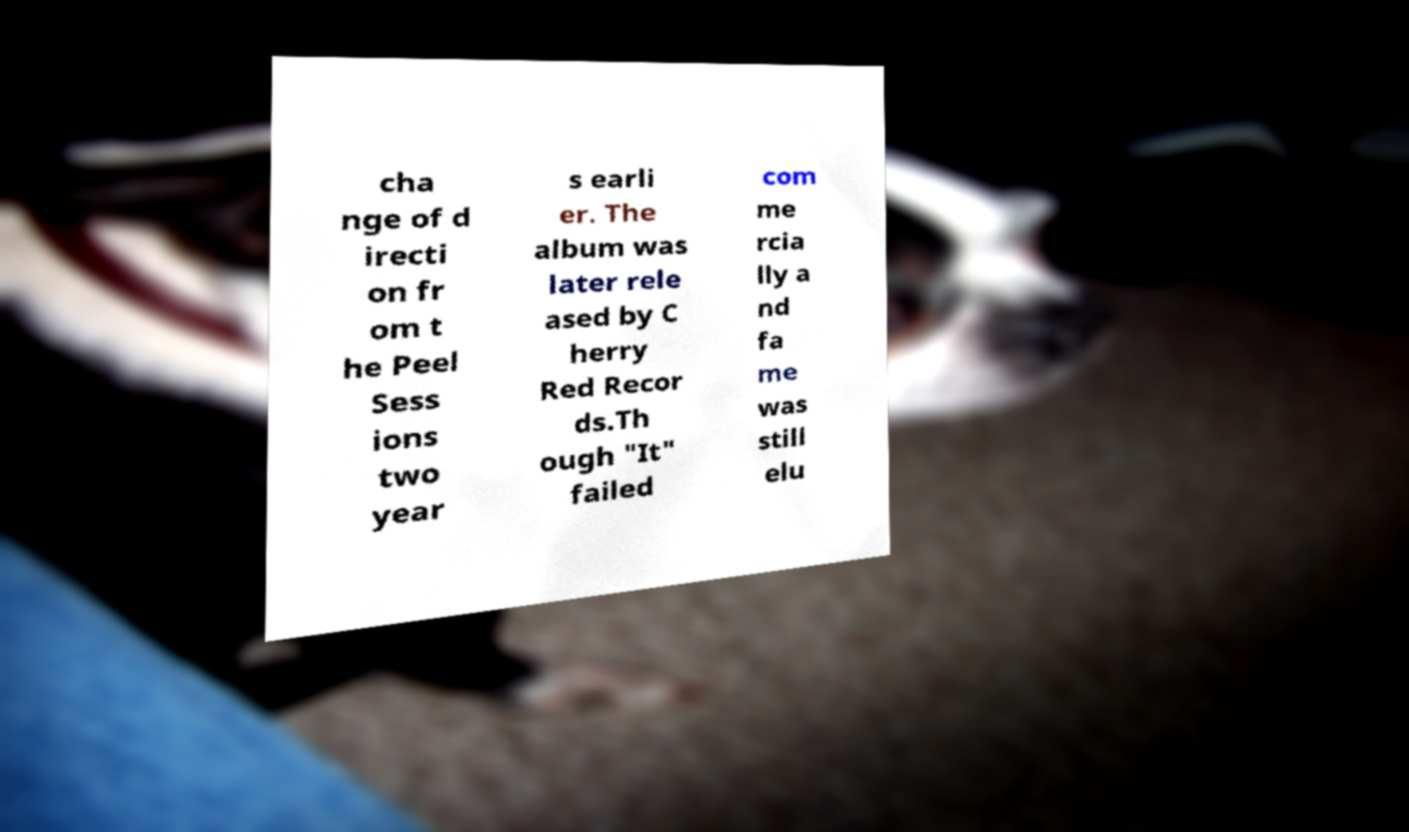Please identify and transcribe the text found in this image. cha nge of d irecti on fr om t he Peel Sess ions two year s earli er. The album was later rele ased by C herry Red Recor ds.Th ough "It" failed com me rcia lly a nd fa me was still elu 